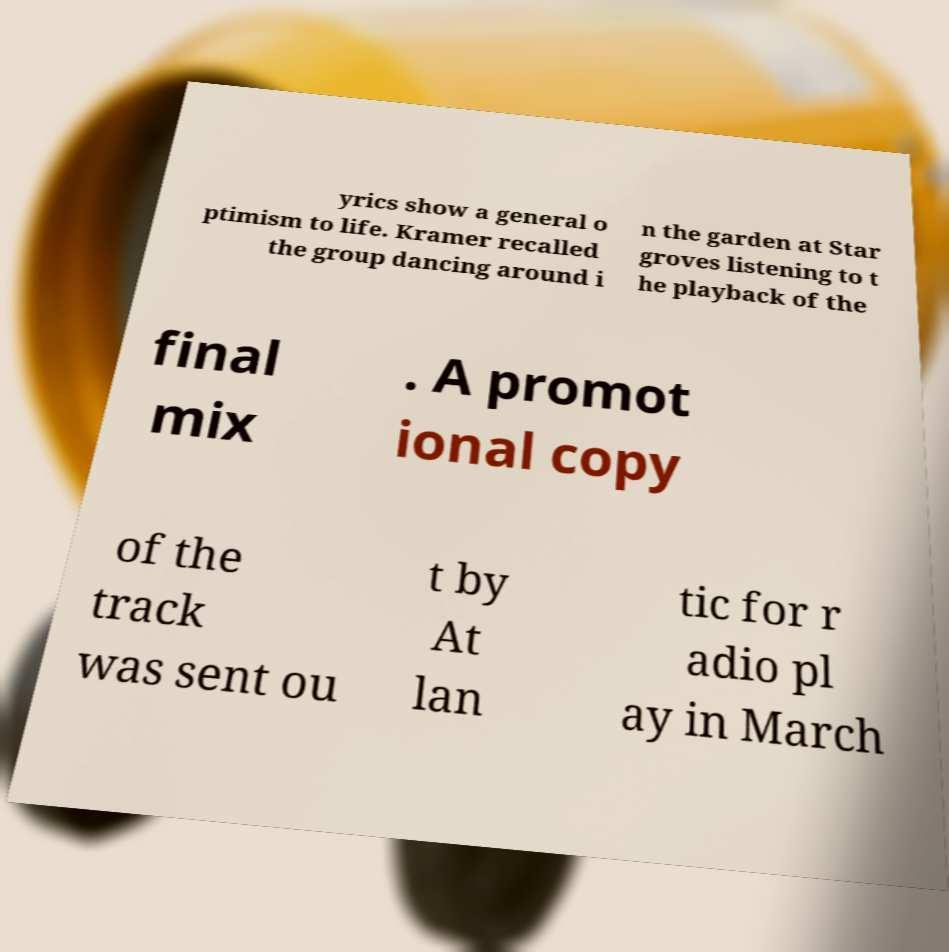Please identify and transcribe the text found in this image. yrics show a general o ptimism to life. Kramer recalled the group dancing around i n the garden at Star groves listening to t he playback of the final mix . A promot ional copy of the track was sent ou t by At lan tic for r adio pl ay in March 